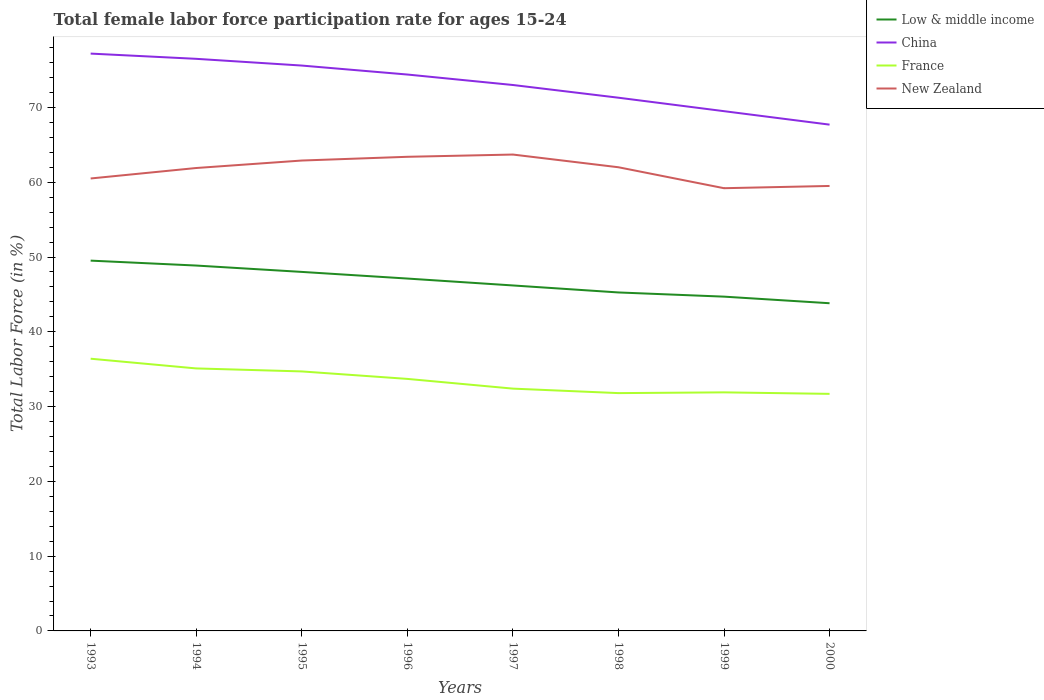How many different coloured lines are there?
Your answer should be compact. 4. Does the line corresponding to Low & middle income intersect with the line corresponding to New Zealand?
Ensure brevity in your answer.  No. Is the number of lines equal to the number of legend labels?
Offer a terse response. Yes. Across all years, what is the maximum female labor force participation rate in China?
Your answer should be very brief. 67.7. In which year was the female labor force participation rate in Low & middle income maximum?
Your answer should be compact. 2000. What is the total female labor force participation rate in France in the graph?
Make the answer very short. 0.2. What is the difference between the highest and the second highest female labor force participation rate in Low & middle income?
Keep it short and to the point. 5.7. What is the difference between the highest and the lowest female labor force participation rate in Low & middle income?
Your answer should be very brief. 4. How many lines are there?
Ensure brevity in your answer.  4. What is the difference between two consecutive major ticks on the Y-axis?
Your answer should be very brief. 10. Does the graph contain any zero values?
Give a very brief answer. No. Where does the legend appear in the graph?
Your answer should be compact. Top right. What is the title of the graph?
Give a very brief answer. Total female labor force participation rate for ages 15-24. Does "Somalia" appear as one of the legend labels in the graph?
Ensure brevity in your answer.  No. What is the label or title of the Y-axis?
Provide a succinct answer. Total Labor Force (in %). What is the Total Labor Force (in %) in Low & middle income in 1993?
Your answer should be very brief. 49.51. What is the Total Labor Force (in %) in China in 1993?
Make the answer very short. 77.2. What is the Total Labor Force (in %) in France in 1993?
Offer a very short reply. 36.4. What is the Total Labor Force (in %) in New Zealand in 1993?
Provide a short and direct response. 60.5. What is the Total Labor Force (in %) of Low & middle income in 1994?
Offer a very short reply. 48.86. What is the Total Labor Force (in %) in China in 1994?
Provide a succinct answer. 76.5. What is the Total Labor Force (in %) of France in 1994?
Give a very brief answer. 35.1. What is the Total Labor Force (in %) of New Zealand in 1994?
Ensure brevity in your answer.  61.9. What is the Total Labor Force (in %) in Low & middle income in 1995?
Your response must be concise. 48.01. What is the Total Labor Force (in %) in China in 1995?
Your answer should be compact. 75.6. What is the Total Labor Force (in %) of France in 1995?
Make the answer very short. 34.7. What is the Total Labor Force (in %) of New Zealand in 1995?
Your answer should be compact. 62.9. What is the Total Labor Force (in %) of Low & middle income in 1996?
Your answer should be compact. 47.12. What is the Total Labor Force (in %) of China in 1996?
Your answer should be very brief. 74.4. What is the Total Labor Force (in %) in France in 1996?
Offer a very short reply. 33.7. What is the Total Labor Force (in %) of New Zealand in 1996?
Offer a very short reply. 63.4. What is the Total Labor Force (in %) in Low & middle income in 1997?
Your response must be concise. 46.2. What is the Total Labor Force (in %) of China in 1997?
Offer a terse response. 73. What is the Total Labor Force (in %) of France in 1997?
Offer a terse response. 32.4. What is the Total Labor Force (in %) of New Zealand in 1997?
Your response must be concise. 63.7. What is the Total Labor Force (in %) of Low & middle income in 1998?
Your answer should be very brief. 45.26. What is the Total Labor Force (in %) in China in 1998?
Keep it short and to the point. 71.3. What is the Total Labor Force (in %) of France in 1998?
Offer a terse response. 31.8. What is the Total Labor Force (in %) of New Zealand in 1998?
Ensure brevity in your answer.  62. What is the Total Labor Force (in %) of Low & middle income in 1999?
Your response must be concise. 44.7. What is the Total Labor Force (in %) in China in 1999?
Provide a short and direct response. 69.5. What is the Total Labor Force (in %) in France in 1999?
Your answer should be very brief. 31.9. What is the Total Labor Force (in %) of New Zealand in 1999?
Your answer should be compact. 59.2. What is the Total Labor Force (in %) in Low & middle income in 2000?
Provide a short and direct response. 43.82. What is the Total Labor Force (in %) in China in 2000?
Your answer should be compact. 67.7. What is the Total Labor Force (in %) of France in 2000?
Ensure brevity in your answer.  31.7. What is the Total Labor Force (in %) of New Zealand in 2000?
Keep it short and to the point. 59.5. Across all years, what is the maximum Total Labor Force (in %) of Low & middle income?
Ensure brevity in your answer.  49.51. Across all years, what is the maximum Total Labor Force (in %) in China?
Offer a terse response. 77.2. Across all years, what is the maximum Total Labor Force (in %) of France?
Offer a terse response. 36.4. Across all years, what is the maximum Total Labor Force (in %) of New Zealand?
Offer a very short reply. 63.7. Across all years, what is the minimum Total Labor Force (in %) of Low & middle income?
Your response must be concise. 43.82. Across all years, what is the minimum Total Labor Force (in %) of China?
Your answer should be compact. 67.7. Across all years, what is the minimum Total Labor Force (in %) of France?
Your answer should be compact. 31.7. Across all years, what is the minimum Total Labor Force (in %) of New Zealand?
Provide a short and direct response. 59.2. What is the total Total Labor Force (in %) in Low & middle income in the graph?
Provide a succinct answer. 373.47. What is the total Total Labor Force (in %) in China in the graph?
Ensure brevity in your answer.  585.2. What is the total Total Labor Force (in %) in France in the graph?
Provide a short and direct response. 267.7. What is the total Total Labor Force (in %) in New Zealand in the graph?
Your answer should be very brief. 493.1. What is the difference between the Total Labor Force (in %) in Low & middle income in 1993 and that in 1994?
Your answer should be very brief. 0.66. What is the difference between the Total Labor Force (in %) of China in 1993 and that in 1994?
Keep it short and to the point. 0.7. What is the difference between the Total Labor Force (in %) of France in 1993 and that in 1994?
Keep it short and to the point. 1.3. What is the difference between the Total Labor Force (in %) of New Zealand in 1993 and that in 1994?
Offer a terse response. -1.4. What is the difference between the Total Labor Force (in %) of Low & middle income in 1993 and that in 1995?
Offer a terse response. 1.51. What is the difference between the Total Labor Force (in %) of China in 1993 and that in 1995?
Your answer should be very brief. 1.6. What is the difference between the Total Labor Force (in %) in Low & middle income in 1993 and that in 1996?
Provide a succinct answer. 2.4. What is the difference between the Total Labor Force (in %) in Low & middle income in 1993 and that in 1997?
Keep it short and to the point. 3.32. What is the difference between the Total Labor Force (in %) in China in 1993 and that in 1997?
Your response must be concise. 4.2. What is the difference between the Total Labor Force (in %) in France in 1993 and that in 1997?
Give a very brief answer. 4. What is the difference between the Total Labor Force (in %) of Low & middle income in 1993 and that in 1998?
Keep it short and to the point. 4.26. What is the difference between the Total Labor Force (in %) in New Zealand in 1993 and that in 1998?
Ensure brevity in your answer.  -1.5. What is the difference between the Total Labor Force (in %) in Low & middle income in 1993 and that in 1999?
Provide a succinct answer. 4.81. What is the difference between the Total Labor Force (in %) in China in 1993 and that in 1999?
Make the answer very short. 7.7. What is the difference between the Total Labor Force (in %) of New Zealand in 1993 and that in 1999?
Offer a terse response. 1.3. What is the difference between the Total Labor Force (in %) in Low & middle income in 1993 and that in 2000?
Your answer should be compact. 5.7. What is the difference between the Total Labor Force (in %) in China in 1993 and that in 2000?
Offer a very short reply. 9.5. What is the difference between the Total Labor Force (in %) in Low & middle income in 1994 and that in 1995?
Offer a terse response. 0.85. What is the difference between the Total Labor Force (in %) in Low & middle income in 1994 and that in 1996?
Offer a very short reply. 1.74. What is the difference between the Total Labor Force (in %) in China in 1994 and that in 1996?
Keep it short and to the point. 2.1. What is the difference between the Total Labor Force (in %) in France in 1994 and that in 1996?
Offer a terse response. 1.4. What is the difference between the Total Labor Force (in %) of New Zealand in 1994 and that in 1996?
Make the answer very short. -1.5. What is the difference between the Total Labor Force (in %) of Low & middle income in 1994 and that in 1997?
Offer a terse response. 2.66. What is the difference between the Total Labor Force (in %) in France in 1994 and that in 1997?
Provide a short and direct response. 2.7. What is the difference between the Total Labor Force (in %) in Low & middle income in 1994 and that in 1998?
Keep it short and to the point. 3.6. What is the difference between the Total Labor Force (in %) in France in 1994 and that in 1998?
Your response must be concise. 3.3. What is the difference between the Total Labor Force (in %) in New Zealand in 1994 and that in 1998?
Offer a terse response. -0.1. What is the difference between the Total Labor Force (in %) of Low & middle income in 1994 and that in 1999?
Ensure brevity in your answer.  4.16. What is the difference between the Total Labor Force (in %) in New Zealand in 1994 and that in 1999?
Your answer should be compact. 2.7. What is the difference between the Total Labor Force (in %) of Low & middle income in 1994 and that in 2000?
Offer a terse response. 5.04. What is the difference between the Total Labor Force (in %) of China in 1994 and that in 2000?
Provide a short and direct response. 8.8. What is the difference between the Total Labor Force (in %) of France in 1994 and that in 2000?
Offer a terse response. 3.4. What is the difference between the Total Labor Force (in %) in New Zealand in 1994 and that in 2000?
Your answer should be very brief. 2.4. What is the difference between the Total Labor Force (in %) in Low & middle income in 1995 and that in 1996?
Keep it short and to the point. 0.89. What is the difference between the Total Labor Force (in %) of France in 1995 and that in 1996?
Ensure brevity in your answer.  1. What is the difference between the Total Labor Force (in %) of Low & middle income in 1995 and that in 1997?
Offer a very short reply. 1.81. What is the difference between the Total Labor Force (in %) of New Zealand in 1995 and that in 1997?
Your response must be concise. -0.8. What is the difference between the Total Labor Force (in %) in Low & middle income in 1995 and that in 1998?
Provide a short and direct response. 2.75. What is the difference between the Total Labor Force (in %) in New Zealand in 1995 and that in 1998?
Offer a terse response. 0.9. What is the difference between the Total Labor Force (in %) in Low & middle income in 1995 and that in 1999?
Provide a short and direct response. 3.31. What is the difference between the Total Labor Force (in %) in China in 1995 and that in 1999?
Provide a short and direct response. 6.1. What is the difference between the Total Labor Force (in %) in New Zealand in 1995 and that in 1999?
Ensure brevity in your answer.  3.7. What is the difference between the Total Labor Force (in %) in Low & middle income in 1995 and that in 2000?
Keep it short and to the point. 4.19. What is the difference between the Total Labor Force (in %) in New Zealand in 1995 and that in 2000?
Provide a succinct answer. 3.4. What is the difference between the Total Labor Force (in %) in Low & middle income in 1996 and that in 1997?
Provide a succinct answer. 0.92. What is the difference between the Total Labor Force (in %) in France in 1996 and that in 1997?
Give a very brief answer. 1.3. What is the difference between the Total Labor Force (in %) of New Zealand in 1996 and that in 1997?
Provide a short and direct response. -0.3. What is the difference between the Total Labor Force (in %) of Low & middle income in 1996 and that in 1998?
Offer a terse response. 1.86. What is the difference between the Total Labor Force (in %) of China in 1996 and that in 1998?
Your answer should be very brief. 3.1. What is the difference between the Total Labor Force (in %) of France in 1996 and that in 1998?
Your answer should be compact. 1.9. What is the difference between the Total Labor Force (in %) in New Zealand in 1996 and that in 1998?
Your answer should be very brief. 1.4. What is the difference between the Total Labor Force (in %) in Low & middle income in 1996 and that in 1999?
Offer a terse response. 2.42. What is the difference between the Total Labor Force (in %) of China in 1996 and that in 1999?
Give a very brief answer. 4.9. What is the difference between the Total Labor Force (in %) of Low & middle income in 1996 and that in 2000?
Your response must be concise. 3.3. What is the difference between the Total Labor Force (in %) in New Zealand in 1996 and that in 2000?
Your answer should be compact. 3.9. What is the difference between the Total Labor Force (in %) in Low & middle income in 1997 and that in 1998?
Offer a terse response. 0.94. What is the difference between the Total Labor Force (in %) in France in 1997 and that in 1998?
Your answer should be very brief. 0.6. What is the difference between the Total Labor Force (in %) in Low & middle income in 1997 and that in 1999?
Your answer should be very brief. 1.5. What is the difference between the Total Labor Force (in %) in China in 1997 and that in 1999?
Your answer should be compact. 3.5. What is the difference between the Total Labor Force (in %) in France in 1997 and that in 1999?
Your response must be concise. 0.5. What is the difference between the Total Labor Force (in %) in New Zealand in 1997 and that in 1999?
Your answer should be very brief. 4.5. What is the difference between the Total Labor Force (in %) in Low & middle income in 1997 and that in 2000?
Your answer should be very brief. 2.38. What is the difference between the Total Labor Force (in %) of China in 1997 and that in 2000?
Keep it short and to the point. 5.3. What is the difference between the Total Labor Force (in %) of France in 1997 and that in 2000?
Provide a short and direct response. 0.7. What is the difference between the Total Labor Force (in %) of Low & middle income in 1998 and that in 1999?
Your answer should be very brief. 0.56. What is the difference between the Total Labor Force (in %) of China in 1998 and that in 1999?
Provide a short and direct response. 1.8. What is the difference between the Total Labor Force (in %) in France in 1998 and that in 1999?
Your response must be concise. -0.1. What is the difference between the Total Labor Force (in %) of Low & middle income in 1998 and that in 2000?
Keep it short and to the point. 1.44. What is the difference between the Total Labor Force (in %) of China in 1998 and that in 2000?
Ensure brevity in your answer.  3.6. What is the difference between the Total Labor Force (in %) in France in 1998 and that in 2000?
Provide a short and direct response. 0.1. What is the difference between the Total Labor Force (in %) of Low & middle income in 1999 and that in 2000?
Offer a terse response. 0.88. What is the difference between the Total Labor Force (in %) in China in 1999 and that in 2000?
Your answer should be very brief. 1.8. What is the difference between the Total Labor Force (in %) in France in 1999 and that in 2000?
Your answer should be very brief. 0.2. What is the difference between the Total Labor Force (in %) in New Zealand in 1999 and that in 2000?
Your response must be concise. -0.3. What is the difference between the Total Labor Force (in %) in Low & middle income in 1993 and the Total Labor Force (in %) in China in 1994?
Keep it short and to the point. -26.98. What is the difference between the Total Labor Force (in %) of Low & middle income in 1993 and the Total Labor Force (in %) of France in 1994?
Your answer should be very brief. 14.41. What is the difference between the Total Labor Force (in %) in Low & middle income in 1993 and the Total Labor Force (in %) in New Zealand in 1994?
Make the answer very short. -12.38. What is the difference between the Total Labor Force (in %) in China in 1993 and the Total Labor Force (in %) in France in 1994?
Provide a short and direct response. 42.1. What is the difference between the Total Labor Force (in %) of France in 1993 and the Total Labor Force (in %) of New Zealand in 1994?
Provide a short and direct response. -25.5. What is the difference between the Total Labor Force (in %) in Low & middle income in 1993 and the Total Labor Force (in %) in China in 1995?
Your answer should be compact. -26.09. What is the difference between the Total Labor Force (in %) in Low & middle income in 1993 and the Total Labor Force (in %) in France in 1995?
Keep it short and to the point. 14.81. What is the difference between the Total Labor Force (in %) in Low & middle income in 1993 and the Total Labor Force (in %) in New Zealand in 1995?
Your answer should be compact. -13.38. What is the difference between the Total Labor Force (in %) in China in 1993 and the Total Labor Force (in %) in France in 1995?
Your answer should be compact. 42.5. What is the difference between the Total Labor Force (in %) in China in 1993 and the Total Labor Force (in %) in New Zealand in 1995?
Provide a succinct answer. 14.3. What is the difference between the Total Labor Force (in %) of France in 1993 and the Total Labor Force (in %) of New Zealand in 1995?
Offer a terse response. -26.5. What is the difference between the Total Labor Force (in %) in Low & middle income in 1993 and the Total Labor Force (in %) in China in 1996?
Ensure brevity in your answer.  -24.89. What is the difference between the Total Labor Force (in %) of Low & middle income in 1993 and the Total Labor Force (in %) of France in 1996?
Your answer should be compact. 15.81. What is the difference between the Total Labor Force (in %) in Low & middle income in 1993 and the Total Labor Force (in %) in New Zealand in 1996?
Your response must be concise. -13.88. What is the difference between the Total Labor Force (in %) of China in 1993 and the Total Labor Force (in %) of France in 1996?
Provide a succinct answer. 43.5. What is the difference between the Total Labor Force (in %) of China in 1993 and the Total Labor Force (in %) of New Zealand in 1996?
Your response must be concise. 13.8. What is the difference between the Total Labor Force (in %) of Low & middle income in 1993 and the Total Labor Force (in %) of China in 1997?
Ensure brevity in your answer.  -23.48. What is the difference between the Total Labor Force (in %) in Low & middle income in 1993 and the Total Labor Force (in %) in France in 1997?
Offer a very short reply. 17.11. What is the difference between the Total Labor Force (in %) in Low & middle income in 1993 and the Total Labor Force (in %) in New Zealand in 1997?
Ensure brevity in your answer.  -14.19. What is the difference between the Total Labor Force (in %) of China in 1993 and the Total Labor Force (in %) of France in 1997?
Offer a terse response. 44.8. What is the difference between the Total Labor Force (in %) of France in 1993 and the Total Labor Force (in %) of New Zealand in 1997?
Your response must be concise. -27.3. What is the difference between the Total Labor Force (in %) of Low & middle income in 1993 and the Total Labor Force (in %) of China in 1998?
Keep it short and to the point. -21.79. What is the difference between the Total Labor Force (in %) of Low & middle income in 1993 and the Total Labor Force (in %) of France in 1998?
Your response must be concise. 17.71. What is the difference between the Total Labor Force (in %) of Low & middle income in 1993 and the Total Labor Force (in %) of New Zealand in 1998?
Ensure brevity in your answer.  -12.48. What is the difference between the Total Labor Force (in %) of China in 1993 and the Total Labor Force (in %) of France in 1998?
Ensure brevity in your answer.  45.4. What is the difference between the Total Labor Force (in %) in France in 1993 and the Total Labor Force (in %) in New Zealand in 1998?
Your answer should be compact. -25.6. What is the difference between the Total Labor Force (in %) in Low & middle income in 1993 and the Total Labor Force (in %) in China in 1999?
Give a very brief answer. -19.98. What is the difference between the Total Labor Force (in %) of Low & middle income in 1993 and the Total Labor Force (in %) of France in 1999?
Offer a very short reply. 17.61. What is the difference between the Total Labor Force (in %) in Low & middle income in 1993 and the Total Labor Force (in %) in New Zealand in 1999?
Your answer should be compact. -9.69. What is the difference between the Total Labor Force (in %) in China in 1993 and the Total Labor Force (in %) in France in 1999?
Keep it short and to the point. 45.3. What is the difference between the Total Labor Force (in %) in France in 1993 and the Total Labor Force (in %) in New Zealand in 1999?
Provide a succinct answer. -22.8. What is the difference between the Total Labor Force (in %) of Low & middle income in 1993 and the Total Labor Force (in %) of China in 2000?
Offer a terse response. -18.18. What is the difference between the Total Labor Force (in %) in Low & middle income in 1993 and the Total Labor Force (in %) in France in 2000?
Offer a terse response. 17.82. What is the difference between the Total Labor Force (in %) in Low & middle income in 1993 and the Total Labor Force (in %) in New Zealand in 2000?
Offer a very short reply. -9.98. What is the difference between the Total Labor Force (in %) in China in 1993 and the Total Labor Force (in %) in France in 2000?
Give a very brief answer. 45.5. What is the difference between the Total Labor Force (in %) in China in 1993 and the Total Labor Force (in %) in New Zealand in 2000?
Provide a short and direct response. 17.7. What is the difference between the Total Labor Force (in %) in France in 1993 and the Total Labor Force (in %) in New Zealand in 2000?
Your answer should be very brief. -23.1. What is the difference between the Total Labor Force (in %) of Low & middle income in 1994 and the Total Labor Force (in %) of China in 1995?
Make the answer very short. -26.74. What is the difference between the Total Labor Force (in %) in Low & middle income in 1994 and the Total Labor Force (in %) in France in 1995?
Give a very brief answer. 14.16. What is the difference between the Total Labor Force (in %) of Low & middle income in 1994 and the Total Labor Force (in %) of New Zealand in 1995?
Ensure brevity in your answer.  -14.04. What is the difference between the Total Labor Force (in %) of China in 1994 and the Total Labor Force (in %) of France in 1995?
Provide a short and direct response. 41.8. What is the difference between the Total Labor Force (in %) in France in 1994 and the Total Labor Force (in %) in New Zealand in 1995?
Ensure brevity in your answer.  -27.8. What is the difference between the Total Labor Force (in %) in Low & middle income in 1994 and the Total Labor Force (in %) in China in 1996?
Provide a short and direct response. -25.54. What is the difference between the Total Labor Force (in %) of Low & middle income in 1994 and the Total Labor Force (in %) of France in 1996?
Give a very brief answer. 15.16. What is the difference between the Total Labor Force (in %) in Low & middle income in 1994 and the Total Labor Force (in %) in New Zealand in 1996?
Provide a short and direct response. -14.54. What is the difference between the Total Labor Force (in %) in China in 1994 and the Total Labor Force (in %) in France in 1996?
Your answer should be very brief. 42.8. What is the difference between the Total Labor Force (in %) of China in 1994 and the Total Labor Force (in %) of New Zealand in 1996?
Your answer should be very brief. 13.1. What is the difference between the Total Labor Force (in %) of France in 1994 and the Total Labor Force (in %) of New Zealand in 1996?
Offer a very short reply. -28.3. What is the difference between the Total Labor Force (in %) of Low & middle income in 1994 and the Total Labor Force (in %) of China in 1997?
Ensure brevity in your answer.  -24.14. What is the difference between the Total Labor Force (in %) of Low & middle income in 1994 and the Total Labor Force (in %) of France in 1997?
Offer a very short reply. 16.46. What is the difference between the Total Labor Force (in %) of Low & middle income in 1994 and the Total Labor Force (in %) of New Zealand in 1997?
Give a very brief answer. -14.84. What is the difference between the Total Labor Force (in %) in China in 1994 and the Total Labor Force (in %) in France in 1997?
Keep it short and to the point. 44.1. What is the difference between the Total Labor Force (in %) in China in 1994 and the Total Labor Force (in %) in New Zealand in 1997?
Your answer should be compact. 12.8. What is the difference between the Total Labor Force (in %) in France in 1994 and the Total Labor Force (in %) in New Zealand in 1997?
Provide a short and direct response. -28.6. What is the difference between the Total Labor Force (in %) of Low & middle income in 1994 and the Total Labor Force (in %) of China in 1998?
Make the answer very short. -22.44. What is the difference between the Total Labor Force (in %) of Low & middle income in 1994 and the Total Labor Force (in %) of France in 1998?
Your response must be concise. 17.06. What is the difference between the Total Labor Force (in %) of Low & middle income in 1994 and the Total Labor Force (in %) of New Zealand in 1998?
Your answer should be compact. -13.14. What is the difference between the Total Labor Force (in %) of China in 1994 and the Total Labor Force (in %) of France in 1998?
Ensure brevity in your answer.  44.7. What is the difference between the Total Labor Force (in %) of China in 1994 and the Total Labor Force (in %) of New Zealand in 1998?
Ensure brevity in your answer.  14.5. What is the difference between the Total Labor Force (in %) in France in 1994 and the Total Labor Force (in %) in New Zealand in 1998?
Give a very brief answer. -26.9. What is the difference between the Total Labor Force (in %) in Low & middle income in 1994 and the Total Labor Force (in %) in China in 1999?
Offer a terse response. -20.64. What is the difference between the Total Labor Force (in %) in Low & middle income in 1994 and the Total Labor Force (in %) in France in 1999?
Offer a terse response. 16.96. What is the difference between the Total Labor Force (in %) in Low & middle income in 1994 and the Total Labor Force (in %) in New Zealand in 1999?
Ensure brevity in your answer.  -10.34. What is the difference between the Total Labor Force (in %) in China in 1994 and the Total Labor Force (in %) in France in 1999?
Your answer should be compact. 44.6. What is the difference between the Total Labor Force (in %) of France in 1994 and the Total Labor Force (in %) of New Zealand in 1999?
Ensure brevity in your answer.  -24.1. What is the difference between the Total Labor Force (in %) of Low & middle income in 1994 and the Total Labor Force (in %) of China in 2000?
Your answer should be compact. -18.84. What is the difference between the Total Labor Force (in %) of Low & middle income in 1994 and the Total Labor Force (in %) of France in 2000?
Your response must be concise. 17.16. What is the difference between the Total Labor Force (in %) of Low & middle income in 1994 and the Total Labor Force (in %) of New Zealand in 2000?
Your response must be concise. -10.64. What is the difference between the Total Labor Force (in %) in China in 1994 and the Total Labor Force (in %) in France in 2000?
Keep it short and to the point. 44.8. What is the difference between the Total Labor Force (in %) of France in 1994 and the Total Labor Force (in %) of New Zealand in 2000?
Your answer should be compact. -24.4. What is the difference between the Total Labor Force (in %) in Low & middle income in 1995 and the Total Labor Force (in %) in China in 1996?
Your answer should be very brief. -26.39. What is the difference between the Total Labor Force (in %) in Low & middle income in 1995 and the Total Labor Force (in %) in France in 1996?
Offer a very short reply. 14.31. What is the difference between the Total Labor Force (in %) in Low & middle income in 1995 and the Total Labor Force (in %) in New Zealand in 1996?
Provide a short and direct response. -15.39. What is the difference between the Total Labor Force (in %) of China in 1995 and the Total Labor Force (in %) of France in 1996?
Your answer should be very brief. 41.9. What is the difference between the Total Labor Force (in %) in France in 1995 and the Total Labor Force (in %) in New Zealand in 1996?
Provide a succinct answer. -28.7. What is the difference between the Total Labor Force (in %) of Low & middle income in 1995 and the Total Labor Force (in %) of China in 1997?
Give a very brief answer. -24.99. What is the difference between the Total Labor Force (in %) of Low & middle income in 1995 and the Total Labor Force (in %) of France in 1997?
Make the answer very short. 15.61. What is the difference between the Total Labor Force (in %) of Low & middle income in 1995 and the Total Labor Force (in %) of New Zealand in 1997?
Keep it short and to the point. -15.69. What is the difference between the Total Labor Force (in %) of China in 1995 and the Total Labor Force (in %) of France in 1997?
Your answer should be compact. 43.2. What is the difference between the Total Labor Force (in %) in China in 1995 and the Total Labor Force (in %) in New Zealand in 1997?
Provide a succinct answer. 11.9. What is the difference between the Total Labor Force (in %) in France in 1995 and the Total Labor Force (in %) in New Zealand in 1997?
Give a very brief answer. -29. What is the difference between the Total Labor Force (in %) in Low & middle income in 1995 and the Total Labor Force (in %) in China in 1998?
Offer a terse response. -23.29. What is the difference between the Total Labor Force (in %) of Low & middle income in 1995 and the Total Labor Force (in %) of France in 1998?
Provide a succinct answer. 16.21. What is the difference between the Total Labor Force (in %) of Low & middle income in 1995 and the Total Labor Force (in %) of New Zealand in 1998?
Offer a very short reply. -13.99. What is the difference between the Total Labor Force (in %) of China in 1995 and the Total Labor Force (in %) of France in 1998?
Make the answer very short. 43.8. What is the difference between the Total Labor Force (in %) in China in 1995 and the Total Labor Force (in %) in New Zealand in 1998?
Offer a very short reply. 13.6. What is the difference between the Total Labor Force (in %) of France in 1995 and the Total Labor Force (in %) of New Zealand in 1998?
Your answer should be compact. -27.3. What is the difference between the Total Labor Force (in %) of Low & middle income in 1995 and the Total Labor Force (in %) of China in 1999?
Your answer should be compact. -21.49. What is the difference between the Total Labor Force (in %) of Low & middle income in 1995 and the Total Labor Force (in %) of France in 1999?
Your response must be concise. 16.11. What is the difference between the Total Labor Force (in %) of Low & middle income in 1995 and the Total Labor Force (in %) of New Zealand in 1999?
Keep it short and to the point. -11.19. What is the difference between the Total Labor Force (in %) of China in 1995 and the Total Labor Force (in %) of France in 1999?
Your answer should be very brief. 43.7. What is the difference between the Total Labor Force (in %) of France in 1995 and the Total Labor Force (in %) of New Zealand in 1999?
Your answer should be compact. -24.5. What is the difference between the Total Labor Force (in %) of Low & middle income in 1995 and the Total Labor Force (in %) of China in 2000?
Your response must be concise. -19.69. What is the difference between the Total Labor Force (in %) in Low & middle income in 1995 and the Total Labor Force (in %) in France in 2000?
Your answer should be very brief. 16.31. What is the difference between the Total Labor Force (in %) in Low & middle income in 1995 and the Total Labor Force (in %) in New Zealand in 2000?
Offer a terse response. -11.49. What is the difference between the Total Labor Force (in %) of China in 1995 and the Total Labor Force (in %) of France in 2000?
Your response must be concise. 43.9. What is the difference between the Total Labor Force (in %) in China in 1995 and the Total Labor Force (in %) in New Zealand in 2000?
Make the answer very short. 16.1. What is the difference between the Total Labor Force (in %) of France in 1995 and the Total Labor Force (in %) of New Zealand in 2000?
Offer a very short reply. -24.8. What is the difference between the Total Labor Force (in %) in Low & middle income in 1996 and the Total Labor Force (in %) in China in 1997?
Your answer should be compact. -25.88. What is the difference between the Total Labor Force (in %) of Low & middle income in 1996 and the Total Labor Force (in %) of France in 1997?
Your answer should be very brief. 14.72. What is the difference between the Total Labor Force (in %) of Low & middle income in 1996 and the Total Labor Force (in %) of New Zealand in 1997?
Offer a very short reply. -16.58. What is the difference between the Total Labor Force (in %) in China in 1996 and the Total Labor Force (in %) in France in 1997?
Your response must be concise. 42. What is the difference between the Total Labor Force (in %) of Low & middle income in 1996 and the Total Labor Force (in %) of China in 1998?
Keep it short and to the point. -24.18. What is the difference between the Total Labor Force (in %) of Low & middle income in 1996 and the Total Labor Force (in %) of France in 1998?
Your answer should be compact. 15.32. What is the difference between the Total Labor Force (in %) in Low & middle income in 1996 and the Total Labor Force (in %) in New Zealand in 1998?
Offer a very short reply. -14.88. What is the difference between the Total Labor Force (in %) in China in 1996 and the Total Labor Force (in %) in France in 1998?
Your response must be concise. 42.6. What is the difference between the Total Labor Force (in %) in China in 1996 and the Total Labor Force (in %) in New Zealand in 1998?
Provide a succinct answer. 12.4. What is the difference between the Total Labor Force (in %) in France in 1996 and the Total Labor Force (in %) in New Zealand in 1998?
Keep it short and to the point. -28.3. What is the difference between the Total Labor Force (in %) in Low & middle income in 1996 and the Total Labor Force (in %) in China in 1999?
Your answer should be very brief. -22.38. What is the difference between the Total Labor Force (in %) in Low & middle income in 1996 and the Total Labor Force (in %) in France in 1999?
Make the answer very short. 15.22. What is the difference between the Total Labor Force (in %) of Low & middle income in 1996 and the Total Labor Force (in %) of New Zealand in 1999?
Keep it short and to the point. -12.08. What is the difference between the Total Labor Force (in %) of China in 1996 and the Total Labor Force (in %) of France in 1999?
Ensure brevity in your answer.  42.5. What is the difference between the Total Labor Force (in %) in China in 1996 and the Total Labor Force (in %) in New Zealand in 1999?
Give a very brief answer. 15.2. What is the difference between the Total Labor Force (in %) in France in 1996 and the Total Labor Force (in %) in New Zealand in 1999?
Offer a terse response. -25.5. What is the difference between the Total Labor Force (in %) in Low & middle income in 1996 and the Total Labor Force (in %) in China in 2000?
Your response must be concise. -20.58. What is the difference between the Total Labor Force (in %) in Low & middle income in 1996 and the Total Labor Force (in %) in France in 2000?
Provide a succinct answer. 15.42. What is the difference between the Total Labor Force (in %) in Low & middle income in 1996 and the Total Labor Force (in %) in New Zealand in 2000?
Provide a short and direct response. -12.38. What is the difference between the Total Labor Force (in %) in China in 1996 and the Total Labor Force (in %) in France in 2000?
Provide a succinct answer. 42.7. What is the difference between the Total Labor Force (in %) in China in 1996 and the Total Labor Force (in %) in New Zealand in 2000?
Your answer should be compact. 14.9. What is the difference between the Total Labor Force (in %) of France in 1996 and the Total Labor Force (in %) of New Zealand in 2000?
Your answer should be very brief. -25.8. What is the difference between the Total Labor Force (in %) of Low & middle income in 1997 and the Total Labor Force (in %) of China in 1998?
Your response must be concise. -25.1. What is the difference between the Total Labor Force (in %) in Low & middle income in 1997 and the Total Labor Force (in %) in France in 1998?
Offer a terse response. 14.4. What is the difference between the Total Labor Force (in %) of Low & middle income in 1997 and the Total Labor Force (in %) of New Zealand in 1998?
Keep it short and to the point. -15.8. What is the difference between the Total Labor Force (in %) of China in 1997 and the Total Labor Force (in %) of France in 1998?
Provide a short and direct response. 41.2. What is the difference between the Total Labor Force (in %) in France in 1997 and the Total Labor Force (in %) in New Zealand in 1998?
Provide a succinct answer. -29.6. What is the difference between the Total Labor Force (in %) in Low & middle income in 1997 and the Total Labor Force (in %) in China in 1999?
Ensure brevity in your answer.  -23.3. What is the difference between the Total Labor Force (in %) in Low & middle income in 1997 and the Total Labor Force (in %) in France in 1999?
Keep it short and to the point. 14.3. What is the difference between the Total Labor Force (in %) in Low & middle income in 1997 and the Total Labor Force (in %) in New Zealand in 1999?
Provide a succinct answer. -13. What is the difference between the Total Labor Force (in %) of China in 1997 and the Total Labor Force (in %) of France in 1999?
Keep it short and to the point. 41.1. What is the difference between the Total Labor Force (in %) of China in 1997 and the Total Labor Force (in %) of New Zealand in 1999?
Your answer should be compact. 13.8. What is the difference between the Total Labor Force (in %) in France in 1997 and the Total Labor Force (in %) in New Zealand in 1999?
Your answer should be very brief. -26.8. What is the difference between the Total Labor Force (in %) of Low & middle income in 1997 and the Total Labor Force (in %) of China in 2000?
Make the answer very short. -21.5. What is the difference between the Total Labor Force (in %) of Low & middle income in 1997 and the Total Labor Force (in %) of France in 2000?
Keep it short and to the point. 14.5. What is the difference between the Total Labor Force (in %) in Low & middle income in 1997 and the Total Labor Force (in %) in New Zealand in 2000?
Keep it short and to the point. -13.3. What is the difference between the Total Labor Force (in %) of China in 1997 and the Total Labor Force (in %) of France in 2000?
Provide a short and direct response. 41.3. What is the difference between the Total Labor Force (in %) of France in 1997 and the Total Labor Force (in %) of New Zealand in 2000?
Ensure brevity in your answer.  -27.1. What is the difference between the Total Labor Force (in %) of Low & middle income in 1998 and the Total Labor Force (in %) of China in 1999?
Keep it short and to the point. -24.24. What is the difference between the Total Labor Force (in %) of Low & middle income in 1998 and the Total Labor Force (in %) of France in 1999?
Keep it short and to the point. 13.36. What is the difference between the Total Labor Force (in %) in Low & middle income in 1998 and the Total Labor Force (in %) in New Zealand in 1999?
Your answer should be very brief. -13.94. What is the difference between the Total Labor Force (in %) in China in 1998 and the Total Labor Force (in %) in France in 1999?
Offer a very short reply. 39.4. What is the difference between the Total Labor Force (in %) of China in 1998 and the Total Labor Force (in %) of New Zealand in 1999?
Your answer should be very brief. 12.1. What is the difference between the Total Labor Force (in %) in France in 1998 and the Total Labor Force (in %) in New Zealand in 1999?
Your answer should be very brief. -27.4. What is the difference between the Total Labor Force (in %) in Low & middle income in 1998 and the Total Labor Force (in %) in China in 2000?
Provide a short and direct response. -22.44. What is the difference between the Total Labor Force (in %) in Low & middle income in 1998 and the Total Labor Force (in %) in France in 2000?
Provide a short and direct response. 13.56. What is the difference between the Total Labor Force (in %) of Low & middle income in 1998 and the Total Labor Force (in %) of New Zealand in 2000?
Offer a terse response. -14.24. What is the difference between the Total Labor Force (in %) in China in 1998 and the Total Labor Force (in %) in France in 2000?
Ensure brevity in your answer.  39.6. What is the difference between the Total Labor Force (in %) in France in 1998 and the Total Labor Force (in %) in New Zealand in 2000?
Your answer should be very brief. -27.7. What is the difference between the Total Labor Force (in %) in Low & middle income in 1999 and the Total Labor Force (in %) in China in 2000?
Ensure brevity in your answer.  -23. What is the difference between the Total Labor Force (in %) of Low & middle income in 1999 and the Total Labor Force (in %) of France in 2000?
Provide a short and direct response. 13. What is the difference between the Total Labor Force (in %) in Low & middle income in 1999 and the Total Labor Force (in %) in New Zealand in 2000?
Provide a short and direct response. -14.8. What is the difference between the Total Labor Force (in %) of China in 1999 and the Total Labor Force (in %) of France in 2000?
Keep it short and to the point. 37.8. What is the difference between the Total Labor Force (in %) of France in 1999 and the Total Labor Force (in %) of New Zealand in 2000?
Provide a short and direct response. -27.6. What is the average Total Labor Force (in %) of Low & middle income per year?
Ensure brevity in your answer.  46.68. What is the average Total Labor Force (in %) of China per year?
Your answer should be compact. 73.15. What is the average Total Labor Force (in %) of France per year?
Offer a very short reply. 33.46. What is the average Total Labor Force (in %) of New Zealand per year?
Provide a succinct answer. 61.64. In the year 1993, what is the difference between the Total Labor Force (in %) in Low & middle income and Total Labor Force (in %) in China?
Make the answer very short. -27.68. In the year 1993, what is the difference between the Total Labor Force (in %) of Low & middle income and Total Labor Force (in %) of France?
Provide a succinct answer. 13.12. In the year 1993, what is the difference between the Total Labor Force (in %) in Low & middle income and Total Labor Force (in %) in New Zealand?
Provide a short and direct response. -10.98. In the year 1993, what is the difference between the Total Labor Force (in %) of China and Total Labor Force (in %) of France?
Provide a succinct answer. 40.8. In the year 1993, what is the difference between the Total Labor Force (in %) of France and Total Labor Force (in %) of New Zealand?
Offer a very short reply. -24.1. In the year 1994, what is the difference between the Total Labor Force (in %) in Low & middle income and Total Labor Force (in %) in China?
Your answer should be compact. -27.64. In the year 1994, what is the difference between the Total Labor Force (in %) in Low & middle income and Total Labor Force (in %) in France?
Ensure brevity in your answer.  13.76. In the year 1994, what is the difference between the Total Labor Force (in %) of Low & middle income and Total Labor Force (in %) of New Zealand?
Your response must be concise. -13.04. In the year 1994, what is the difference between the Total Labor Force (in %) in China and Total Labor Force (in %) in France?
Offer a terse response. 41.4. In the year 1994, what is the difference between the Total Labor Force (in %) of France and Total Labor Force (in %) of New Zealand?
Keep it short and to the point. -26.8. In the year 1995, what is the difference between the Total Labor Force (in %) in Low & middle income and Total Labor Force (in %) in China?
Your answer should be very brief. -27.59. In the year 1995, what is the difference between the Total Labor Force (in %) in Low & middle income and Total Labor Force (in %) in France?
Ensure brevity in your answer.  13.31. In the year 1995, what is the difference between the Total Labor Force (in %) of Low & middle income and Total Labor Force (in %) of New Zealand?
Your answer should be compact. -14.89. In the year 1995, what is the difference between the Total Labor Force (in %) of China and Total Labor Force (in %) of France?
Give a very brief answer. 40.9. In the year 1995, what is the difference between the Total Labor Force (in %) in France and Total Labor Force (in %) in New Zealand?
Keep it short and to the point. -28.2. In the year 1996, what is the difference between the Total Labor Force (in %) in Low & middle income and Total Labor Force (in %) in China?
Provide a succinct answer. -27.28. In the year 1996, what is the difference between the Total Labor Force (in %) of Low & middle income and Total Labor Force (in %) of France?
Offer a very short reply. 13.42. In the year 1996, what is the difference between the Total Labor Force (in %) of Low & middle income and Total Labor Force (in %) of New Zealand?
Offer a terse response. -16.28. In the year 1996, what is the difference between the Total Labor Force (in %) in China and Total Labor Force (in %) in France?
Your answer should be very brief. 40.7. In the year 1996, what is the difference between the Total Labor Force (in %) in France and Total Labor Force (in %) in New Zealand?
Provide a short and direct response. -29.7. In the year 1997, what is the difference between the Total Labor Force (in %) in Low & middle income and Total Labor Force (in %) in China?
Offer a very short reply. -26.8. In the year 1997, what is the difference between the Total Labor Force (in %) of Low & middle income and Total Labor Force (in %) of France?
Your response must be concise. 13.8. In the year 1997, what is the difference between the Total Labor Force (in %) of Low & middle income and Total Labor Force (in %) of New Zealand?
Offer a very short reply. -17.5. In the year 1997, what is the difference between the Total Labor Force (in %) of China and Total Labor Force (in %) of France?
Offer a very short reply. 40.6. In the year 1997, what is the difference between the Total Labor Force (in %) in China and Total Labor Force (in %) in New Zealand?
Give a very brief answer. 9.3. In the year 1997, what is the difference between the Total Labor Force (in %) of France and Total Labor Force (in %) of New Zealand?
Give a very brief answer. -31.3. In the year 1998, what is the difference between the Total Labor Force (in %) in Low & middle income and Total Labor Force (in %) in China?
Your answer should be very brief. -26.04. In the year 1998, what is the difference between the Total Labor Force (in %) in Low & middle income and Total Labor Force (in %) in France?
Ensure brevity in your answer.  13.46. In the year 1998, what is the difference between the Total Labor Force (in %) in Low & middle income and Total Labor Force (in %) in New Zealand?
Make the answer very short. -16.74. In the year 1998, what is the difference between the Total Labor Force (in %) in China and Total Labor Force (in %) in France?
Offer a very short reply. 39.5. In the year 1998, what is the difference between the Total Labor Force (in %) in France and Total Labor Force (in %) in New Zealand?
Provide a short and direct response. -30.2. In the year 1999, what is the difference between the Total Labor Force (in %) in Low & middle income and Total Labor Force (in %) in China?
Provide a short and direct response. -24.8. In the year 1999, what is the difference between the Total Labor Force (in %) of Low & middle income and Total Labor Force (in %) of France?
Give a very brief answer. 12.8. In the year 1999, what is the difference between the Total Labor Force (in %) in Low & middle income and Total Labor Force (in %) in New Zealand?
Your answer should be very brief. -14.5. In the year 1999, what is the difference between the Total Labor Force (in %) of China and Total Labor Force (in %) of France?
Give a very brief answer. 37.6. In the year 1999, what is the difference between the Total Labor Force (in %) of France and Total Labor Force (in %) of New Zealand?
Your answer should be compact. -27.3. In the year 2000, what is the difference between the Total Labor Force (in %) in Low & middle income and Total Labor Force (in %) in China?
Offer a terse response. -23.88. In the year 2000, what is the difference between the Total Labor Force (in %) of Low & middle income and Total Labor Force (in %) of France?
Provide a succinct answer. 12.12. In the year 2000, what is the difference between the Total Labor Force (in %) of Low & middle income and Total Labor Force (in %) of New Zealand?
Your answer should be compact. -15.68. In the year 2000, what is the difference between the Total Labor Force (in %) of China and Total Labor Force (in %) of France?
Ensure brevity in your answer.  36. In the year 2000, what is the difference between the Total Labor Force (in %) in France and Total Labor Force (in %) in New Zealand?
Ensure brevity in your answer.  -27.8. What is the ratio of the Total Labor Force (in %) of Low & middle income in 1993 to that in 1994?
Your response must be concise. 1.01. What is the ratio of the Total Labor Force (in %) in China in 1993 to that in 1994?
Your response must be concise. 1.01. What is the ratio of the Total Labor Force (in %) of France in 1993 to that in 1994?
Your answer should be compact. 1.04. What is the ratio of the Total Labor Force (in %) in New Zealand in 1993 to that in 1994?
Your response must be concise. 0.98. What is the ratio of the Total Labor Force (in %) of Low & middle income in 1993 to that in 1995?
Give a very brief answer. 1.03. What is the ratio of the Total Labor Force (in %) of China in 1993 to that in 1995?
Ensure brevity in your answer.  1.02. What is the ratio of the Total Labor Force (in %) of France in 1993 to that in 1995?
Provide a succinct answer. 1.05. What is the ratio of the Total Labor Force (in %) of New Zealand in 1993 to that in 1995?
Your answer should be compact. 0.96. What is the ratio of the Total Labor Force (in %) of Low & middle income in 1993 to that in 1996?
Ensure brevity in your answer.  1.05. What is the ratio of the Total Labor Force (in %) of China in 1993 to that in 1996?
Provide a short and direct response. 1.04. What is the ratio of the Total Labor Force (in %) in France in 1993 to that in 1996?
Offer a very short reply. 1.08. What is the ratio of the Total Labor Force (in %) of New Zealand in 1993 to that in 1996?
Offer a very short reply. 0.95. What is the ratio of the Total Labor Force (in %) in Low & middle income in 1993 to that in 1997?
Your answer should be very brief. 1.07. What is the ratio of the Total Labor Force (in %) in China in 1993 to that in 1997?
Make the answer very short. 1.06. What is the ratio of the Total Labor Force (in %) of France in 1993 to that in 1997?
Make the answer very short. 1.12. What is the ratio of the Total Labor Force (in %) of New Zealand in 1993 to that in 1997?
Provide a succinct answer. 0.95. What is the ratio of the Total Labor Force (in %) of Low & middle income in 1993 to that in 1998?
Provide a short and direct response. 1.09. What is the ratio of the Total Labor Force (in %) of China in 1993 to that in 1998?
Your response must be concise. 1.08. What is the ratio of the Total Labor Force (in %) of France in 1993 to that in 1998?
Give a very brief answer. 1.14. What is the ratio of the Total Labor Force (in %) of New Zealand in 1993 to that in 1998?
Offer a very short reply. 0.98. What is the ratio of the Total Labor Force (in %) of Low & middle income in 1993 to that in 1999?
Provide a short and direct response. 1.11. What is the ratio of the Total Labor Force (in %) of China in 1993 to that in 1999?
Provide a succinct answer. 1.11. What is the ratio of the Total Labor Force (in %) in France in 1993 to that in 1999?
Provide a short and direct response. 1.14. What is the ratio of the Total Labor Force (in %) of Low & middle income in 1993 to that in 2000?
Your answer should be very brief. 1.13. What is the ratio of the Total Labor Force (in %) in China in 1993 to that in 2000?
Your answer should be compact. 1.14. What is the ratio of the Total Labor Force (in %) in France in 1993 to that in 2000?
Offer a very short reply. 1.15. What is the ratio of the Total Labor Force (in %) in New Zealand in 1993 to that in 2000?
Keep it short and to the point. 1.02. What is the ratio of the Total Labor Force (in %) of Low & middle income in 1994 to that in 1995?
Provide a short and direct response. 1.02. What is the ratio of the Total Labor Force (in %) in China in 1994 to that in 1995?
Make the answer very short. 1.01. What is the ratio of the Total Labor Force (in %) in France in 1994 to that in 1995?
Give a very brief answer. 1.01. What is the ratio of the Total Labor Force (in %) of New Zealand in 1994 to that in 1995?
Your answer should be very brief. 0.98. What is the ratio of the Total Labor Force (in %) of Low & middle income in 1994 to that in 1996?
Provide a short and direct response. 1.04. What is the ratio of the Total Labor Force (in %) of China in 1994 to that in 1996?
Ensure brevity in your answer.  1.03. What is the ratio of the Total Labor Force (in %) in France in 1994 to that in 1996?
Your answer should be compact. 1.04. What is the ratio of the Total Labor Force (in %) in New Zealand in 1994 to that in 1996?
Your answer should be very brief. 0.98. What is the ratio of the Total Labor Force (in %) of Low & middle income in 1994 to that in 1997?
Your response must be concise. 1.06. What is the ratio of the Total Labor Force (in %) of China in 1994 to that in 1997?
Provide a succinct answer. 1.05. What is the ratio of the Total Labor Force (in %) of France in 1994 to that in 1997?
Your answer should be compact. 1.08. What is the ratio of the Total Labor Force (in %) of New Zealand in 1994 to that in 1997?
Your response must be concise. 0.97. What is the ratio of the Total Labor Force (in %) in Low & middle income in 1994 to that in 1998?
Keep it short and to the point. 1.08. What is the ratio of the Total Labor Force (in %) of China in 1994 to that in 1998?
Ensure brevity in your answer.  1.07. What is the ratio of the Total Labor Force (in %) in France in 1994 to that in 1998?
Keep it short and to the point. 1.1. What is the ratio of the Total Labor Force (in %) in New Zealand in 1994 to that in 1998?
Ensure brevity in your answer.  1. What is the ratio of the Total Labor Force (in %) in Low & middle income in 1994 to that in 1999?
Your response must be concise. 1.09. What is the ratio of the Total Labor Force (in %) of China in 1994 to that in 1999?
Offer a very short reply. 1.1. What is the ratio of the Total Labor Force (in %) of France in 1994 to that in 1999?
Make the answer very short. 1.1. What is the ratio of the Total Labor Force (in %) of New Zealand in 1994 to that in 1999?
Your answer should be compact. 1.05. What is the ratio of the Total Labor Force (in %) in Low & middle income in 1994 to that in 2000?
Your response must be concise. 1.11. What is the ratio of the Total Labor Force (in %) of China in 1994 to that in 2000?
Offer a terse response. 1.13. What is the ratio of the Total Labor Force (in %) of France in 1994 to that in 2000?
Make the answer very short. 1.11. What is the ratio of the Total Labor Force (in %) of New Zealand in 1994 to that in 2000?
Offer a terse response. 1.04. What is the ratio of the Total Labor Force (in %) in Low & middle income in 1995 to that in 1996?
Make the answer very short. 1.02. What is the ratio of the Total Labor Force (in %) of China in 1995 to that in 1996?
Provide a succinct answer. 1.02. What is the ratio of the Total Labor Force (in %) in France in 1995 to that in 1996?
Keep it short and to the point. 1.03. What is the ratio of the Total Labor Force (in %) in New Zealand in 1995 to that in 1996?
Offer a terse response. 0.99. What is the ratio of the Total Labor Force (in %) of Low & middle income in 1995 to that in 1997?
Keep it short and to the point. 1.04. What is the ratio of the Total Labor Force (in %) of China in 1995 to that in 1997?
Your answer should be very brief. 1.04. What is the ratio of the Total Labor Force (in %) of France in 1995 to that in 1997?
Provide a short and direct response. 1.07. What is the ratio of the Total Labor Force (in %) in New Zealand in 1995 to that in 1997?
Give a very brief answer. 0.99. What is the ratio of the Total Labor Force (in %) of Low & middle income in 1995 to that in 1998?
Keep it short and to the point. 1.06. What is the ratio of the Total Labor Force (in %) of China in 1995 to that in 1998?
Make the answer very short. 1.06. What is the ratio of the Total Labor Force (in %) of France in 1995 to that in 1998?
Offer a terse response. 1.09. What is the ratio of the Total Labor Force (in %) of New Zealand in 1995 to that in 1998?
Your response must be concise. 1.01. What is the ratio of the Total Labor Force (in %) of Low & middle income in 1995 to that in 1999?
Your answer should be very brief. 1.07. What is the ratio of the Total Labor Force (in %) in China in 1995 to that in 1999?
Your response must be concise. 1.09. What is the ratio of the Total Labor Force (in %) of France in 1995 to that in 1999?
Ensure brevity in your answer.  1.09. What is the ratio of the Total Labor Force (in %) in New Zealand in 1995 to that in 1999?
Your answer should be very brief. 1.06. What is the ratio of the Total Labor Force (in %) of Low & middle income in 1995 to that in 2000?
Ensure brevity in your answer.  1.1. What is the ratio of the Total Labor Force (in %) in China in 1995 to that in 2000?
Your answer should be very brief. 1.12. What is the ratio of the Total Labor Force (in %) of France in 1995 to that in 2000?
Provide a short and direct response. 1.09. What is the ratio of the Total Labor Force (in %) of New Zealand in 1995 to that in 2000?
Your answer should be compact. 1.06. What is the ratio of the Total Labor Force (in %) of Low & middle income in 1996 to that in 1997?
Give a very brief answer. 1.02. What is the ratio of the Total Labor Force (in %) of China in 1996 to that in 1997?
Your answer should be very brief. 1.02. What is the ratio of the Total Labor Force (in %) of France in 1996 to that in 1997?
Give a very brief answer. 1.04. What is the ratio of the Total Labor Force (in %) of Low & middle income in 1996 to that in 1998?
Offer a very short reply. 1.04. What is the ratio of the Total Labor Force (in %) in China in 1996 to that in 1998?
Your answer should be compact. 1.04. What is the ratio of the Total Labor Force (in %) of France in 1996 to that in 1998?
Give a very brief answer. 1.06. What is the ratio of the Total Labor Force (in %) of New Zealand in 1996 to that in 1998?
Give a very brief answer. 1.02. What is the ratio of the Total Labor Force (in %) in Low & middle income in 1996 to that in 1999?
Your answer should be very brief. 1.05. What is the ratio of the Total Labor Force (in %) in China in 1996 to that in 1999?
Provide a short and direct response. 1.07. What is the ratio of the Total Labor Force (in %) in France in 1996 to that in 1999?
Keep it short and to the point. 1.06. What is the ratio of the Total Labor Force (in %) in New Zealand in 1996 to that in 1999?
Keep it short and to the point. 1.07. What is the ratio of the Total Labor Force (in %) of Low & middle income in 1996 to that in 2000?
Give a very brief answer. 1.08. What is the ratio of the Total Labor Force (in %) of China in 1996 to that in 2000?
Keep it short and to the point. 1.1. What is the ratio of the Total Labor Force (in %) of France in 1996 to that in 2000?
Make the answer very short. 1.06. What is the ratio of the Total Labor Force (in %) in New Zealand in 1996 to that in 2000?
Provide a short and direct response. 1.07. What is the ratio of the Total Labor Force (in %) in Low & middle income in 1997 to that in 1998?
Give a very brief answer. 1.02. What is the ratio of the Total Labor Force (in %) of China in 1997 to that in 1998?
Your response must be concise. 1.02. What is the ratio of the Total Labor Force (in %) in France in 1997 to that in 1998?
Your answer should be very brief. 1.02. What is the ratio of the Total Labor Force (in %) of New Zealand in 1997 to that in 1998?
Your answer should be very brief. 1.03. What is the ratio of the Total Labor Force (in %) of Low & middle income in 1997 to that in 1999?
Offer a terse response. 1.03. What is the ratio of the Total Labor Force (in %) of China in 1997 to that in 1999?
Offer a very short reply. 1.05. What is the ratio of the Total Labor Force (in %) of France in 1997 to that in 1999?
Provide a succinct answer. 1.02. What is the ratio of the Total Labor Force (in %) of New Zealand in 1997 to that in 1999?
Ensure brevity in your answer.  1.08. What is the ratio of the Total Labor Force (in %) in Low & middle income in 1997 to that in 2000?
Keep it short and to the point. 1.05. What is the ratio of the Total Labor Force (in %) of China in 1997 to that in 2000?
Give a very brief answer. 1.08. What is the ratio of the Total Labor Force (in %) in France in 1997 to that in 2000?
Keep it short and to the point. 1.02. What is the ratio of the Total Labor Force (in %) of New Zealand in 1997 to that in 2000?
Your response must be concise. 1.07. What is the ratio of the Total Labor Force (in %) of Low & middle income in 1998 to that in 1999?
Make the answer very short. 1.01. What is the ratio of the Total Labor Force (in %) in China in 1998 to that in 1999?
Your answer should be very brief. 1.03. What is the ratio of the Total Labor Force (in %) of New Zealand in 1998 to that in 1999?
Ensure brevity in your answer.  1.05. What is the ratio of the Total Labor Force (in %) in Low & middle income in 1998 to that in 2000?
Provide a succinct answer. 1.03. What is the ratio of the Total Labor Force (in %) in China in 1998 to that in 2000?
Make the answer very short. 1.05. What is the ratio of the Total Labor Force (in %) of France in 1998 to that in 2000?
Keep it short and to the point. 1. What is the ratio of the Total Labor Force (in %) of New Zealand in 1998 to that in 2000?
Keep it short and to the point. 1.04. What is the ratio of the Total Labor Force (in %) in Low & middle income in 1999 to that in 2000?
Offer a very short reply. 1.02. What is the ratio of the Total Labor Force (in %) in China in 1999 to that in 2000?
Offer a terse response. 1.03. What is the ratio of the Total Labor Force (in %) in France in 1999 to that in 2000?
Your response must be concise. 1.01. What is the difference between the highest and the second highest Total Labor Force (in %) of Low & middle income?
Give a very brief answer. 0.66. What is the difference between the highest and the second highest Total Labor Force (in %) of China?
Give a very brief answer. 0.7. What is the difference between the highest and the second highest Total Labor Force (in %) in France?
Keep it short and to the point. 1.3. What is the difference between the highest and the second highest Total Labor Force (in %) in New Zealand?
Give a very brief answer. 0.3. What is the difference between the highest and the lowest Total Labor Force (in %) in Low & middle income?
Offer a terse response. 5.7. What is the difference between the highest and the lowest Total Labor Force (in %) in China?
Offer a terse response. 9.5. What is the difference between the highest and the lowest Total Labor Force (in %) of France?
Make the answer very short. 4.7. What is the difference between the highest and the lowest Total Labor Force (in %) in New Zealand?
Make the answer very short. 4.5. 